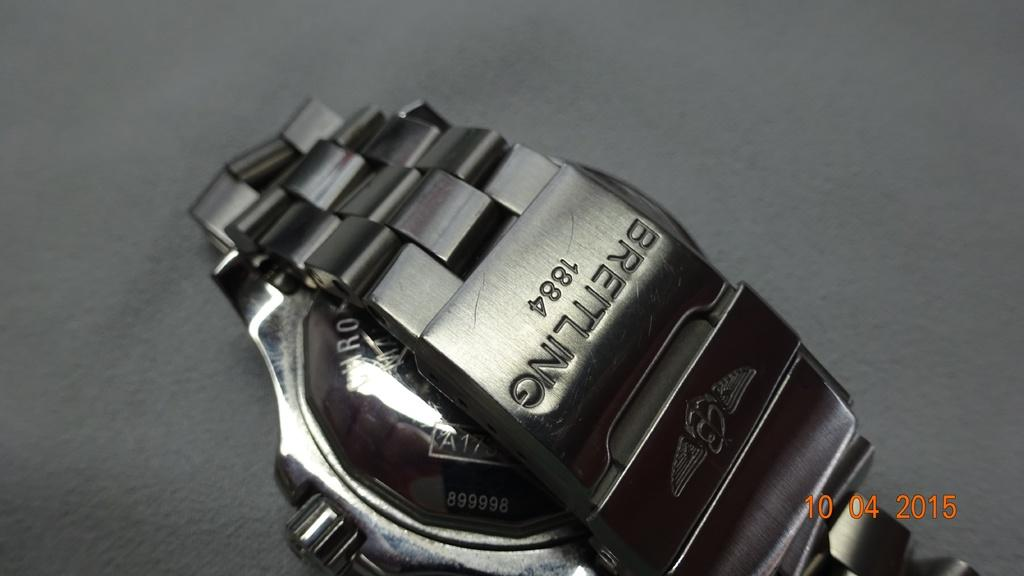<image>
Offer a succinct explanation of the picture presented. The watchband for a Breitling watch shows a year of 1884. 